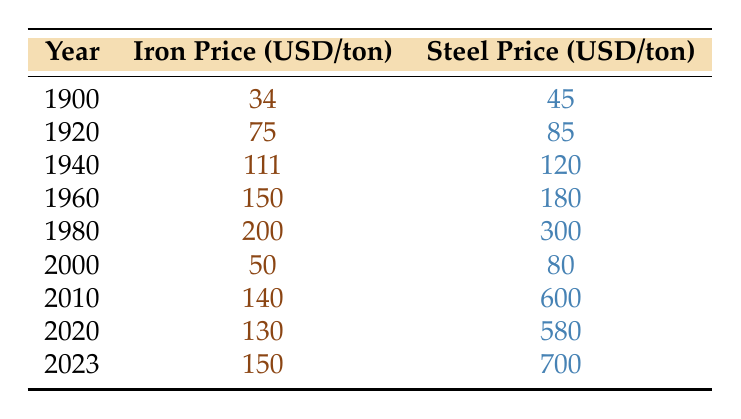What was the price of iron in 1980? The table shows that the price of iron in 1980 was 200 USD per ton.
Answer: 200 What was the difference in steel prices between the years 2000 and 2010? In 2000, the steel price was 80 USD per ton, and in 2010, it was 600 USD per ton. The difference is 600 - 80 = 520 USD.
Answer: 520 Did the price of iron decrease from 1980 to 2000? Yes, the price of iron in 1980 was 200 USD per ton, and in 2000, it decreased to 50 USD per ton.
Answer: Yes What was the average price of steel from 1900 to 2023? First, add up the steel prices across the years: 45 + 85 + 120 + 180 + 300 + 80 + 600 + 580 + 700 = 2190 USD. There are 9 data points, so the average price is 2190 / 9 = 243.33 USD per ton.
Answer: 243.33 In which year did the price of steel first exceed 600 USD per ton? According to the table, the steel price first exceeded 600 USD in 2010, when it was 600 USD, and it increased to 700 USD in 2023 but never exceeded 600 USD before that.
Answer: 2010 What was the highest recorded price of iron, and in what year did it occur? The highest recorded price of iron was 200 USD per ton, which occurred in 1980.
Answer: 200 in 1980 Is it true that the price of steel decreased between 2010 and 2020? No, the price of steel increased from 600 USD in 2010 to 580 USD in 2020, indicating a decrease which is incorrect.
Answer: No What is the ratio of the steel price in 2023 to the steel price in 1900? The steel price in 2023 is 700 USD per ton, and in 1900, it was 45 USD per ton. The ratio is 700 / 45 = approximately 15.56.
Answer: 15.56 